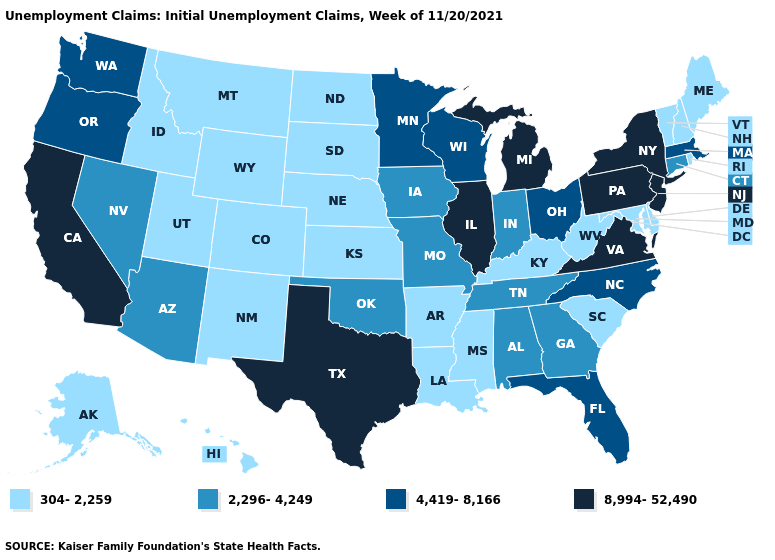Does the first symbol in the legend represent the smallest category?
Be succinct. Yes. Does Kansas have a lower value than Rhode Island?
Concise answer only. No. What is the value of Kansas?
Answer briefly. 304-2,259. What is the value of Texas?
Be succinct. 8,994-52,490. Which states hav the highest value in the Northeast?
Concise answer only. New Jersey, New York, Pennsylvania. Name the states that have a value in the range 2,296-4,249?
Keep it brief. Alabama, Arizona, Connecticut, Georgia, Indiana, Iowa, Missouri, Nevada, Oklahoma, Tennessee. What is the value of Massachusetts?
Give a very brief answer. 4,419-8,166. Does North Dakota have a lower value than Montana?
Be succinct. No. What is the value of New York?
Concise answer only. 8,994-52,490. What is the lowest value in states that border Iowa?
Keep it brief. 304-2,259. Does Texas have the highest value in the South?
Give a very brief answer. Yes. What is the highest value in the USA?
Give a very brief answer. 8,994-52,490. Does North Carolina have the lowest value in the South?
Short answer required. No. What is the value of Missouri?
Be succinct. 2,296-4,249. What is the value of Michigan?
Be succinct. 8,994-52,490. 